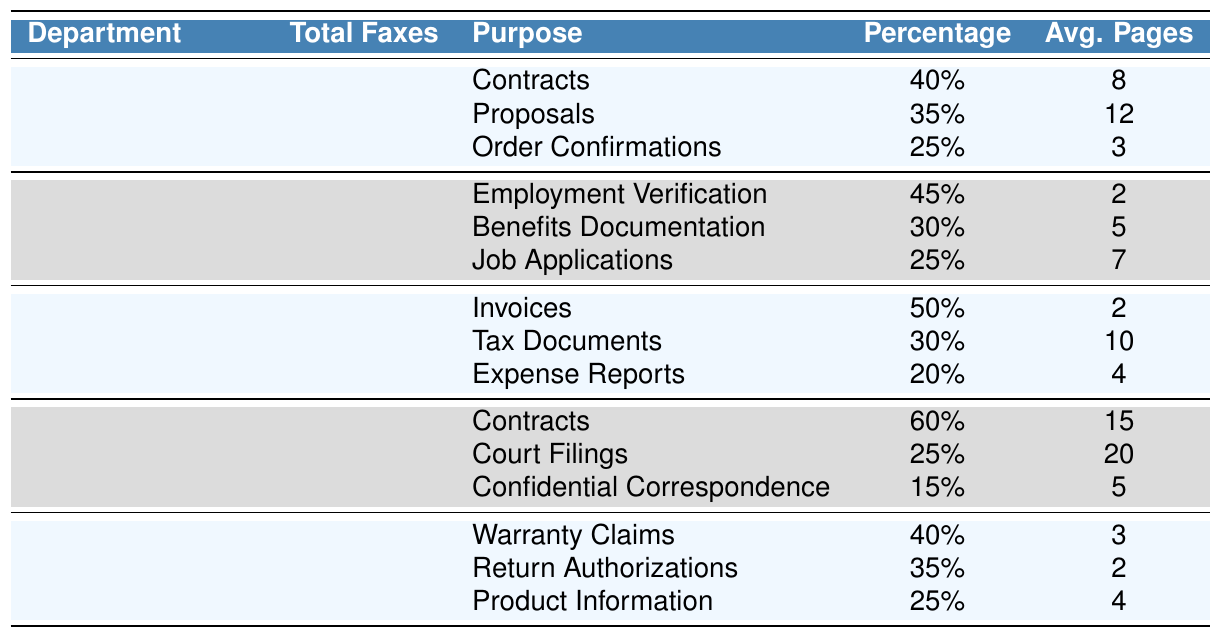What is the total number of faxes sent by the Sales department monthly? Referring to the table, the Total Faxes Sent for the Sales department is explicitly listed as 450.
Answer: 450 Which department sends the most faxes? By comparing the Total Faxes Sent across all departments in the table, Sales has the highest with 450, followed by Finance with 320.
Answer: Sales What is the purpose with the highest percentage of faxes sent in the Legal department? Looking at the Legal department's breakdown, Contracts have the highest percentage at 60%.
Answer: Contracts How many faxes are sent for Order Confirmations in the Sales department? In the Sales department's breakdown, Order Confirmations account for 25% of 450, which is (0.25 * 450) = 112.5 faxes. However, practical consideration means we'll round this to the nearest whole fax, which is 113.
Answer: 113 What is the average number of pages sent for tax documents in the Finance department? The table lists the Average Pages for Tax Documents in the Finance department as 10 pages.
Answer: 10 Which department has the lowest total faxes sent? By inspecting the Total Faxes Sent for all departments, Customer Service has the lowest total at 150 faxes, compared to the others.
Answer: Customer Service If the Finance department's faxes consist of 50% invoices, how many invoices are sent monthly? Given that 50% of the Finance department's total of 320 faxes are invoices, the calculation is (0.50 * 320) = 160 invoices.
Answer: 160 What percentage of faxes in the Human Resources department are for Employment Verification? The table specifies that Employment Verification constitutes 45% of the Human Resources department's total faxes sent.
Answer: 45% Calculate the total pages sent for Benefits Documentation in the Human Resources department. Benefits Documentation has a percentage of 30% of the total 280 faxes, leading to (0.30 * 280) = 84. Then, it averages 5 pages, hence total pages = (84 * 5 = 420) pages.
Answer: 420 Is it true that the Legal department sends more faxes for Court Filings than Confidential Correspondence? The table states that the Legal department sends 25% for Court Filings and 15% for Confidential Correspondence. Since 25% > 15%, the statement is true.
Answer: Yes Which department primarily uses faxing for warranty claims, and what percentage do they represent? The Customer Service department primarily uses faxing for Warranty Claims, which represent 40% of their total faxes sent.
Answer: Customer Service, 40% In the entire organization, how many total faxes are sent across all departments monthly? The total for each department is as follows: Sales (450) + Human Resources (280) + Finance (320) + Legal (180) + Customer Service (150) = 1380 total faxes sent monthly.
Answer: 1380 